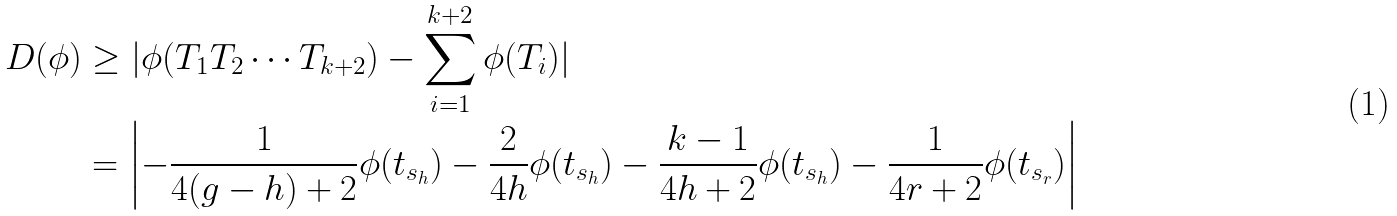<formula> <loc_0><loc_0><loc_500><loc_500>D ( \phi ) & \geq | \phi ( T _ { 1 } T _ { 2 } \cdots T _ { k + 2 } ) - \sum _ { i = 1 } ^ { k + 2 } \phi ( T _ { i } ) | \\ & = \left | - \frac { 1 } { 4 ( g - h ) + 2 } \phi ( t _ { s _ { h } } ) - \frac { 2 } { 4 h } \phi ( t _ { s _ { h } } ) - \frac { k - 1 } { 4 h + 2 } \phi ( t _ { s _ { h } } ) - \frac { 1 } { 4 r + 2 } \phi ( t _ { s _ { r } } ) \right |</formula> 